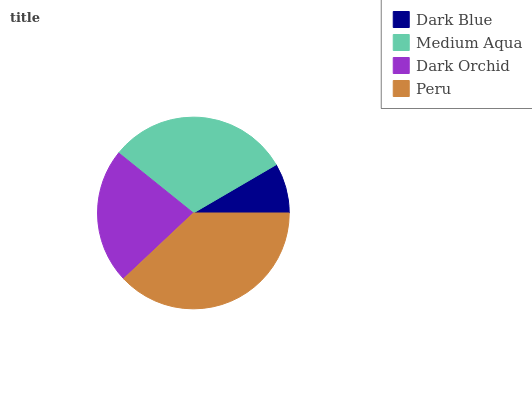Is Dark Blue the minimum?
Answer yes or no. Yes. Is Peru the maximum?
Answer yes or no. Yes. Is Medium Aqua the minimum?
Answer yes or no. No. Is Medium Aqua the maximum?
Answer yes or no. No. Is Medium Aqua greater than Dark Blue?
Answer yes or no. Yes. Is Dark Blue less than Medium Aqua?
Answer yes or no. Yes. Is Dark Blue greater than Medium Aqua?
Answer yes or no. No. Is Medium Aqua less than Dark Blue?
Answer yes or no. No. Is Medium Aqua the high median?
Answer yes or no. Yes. Is Dark Orchid the low median?
Answer yes or no. Yes. Is Peru the high median?
Answer yes or no. No. Is Dark Blue the low median?
Answer yes or no. No. 